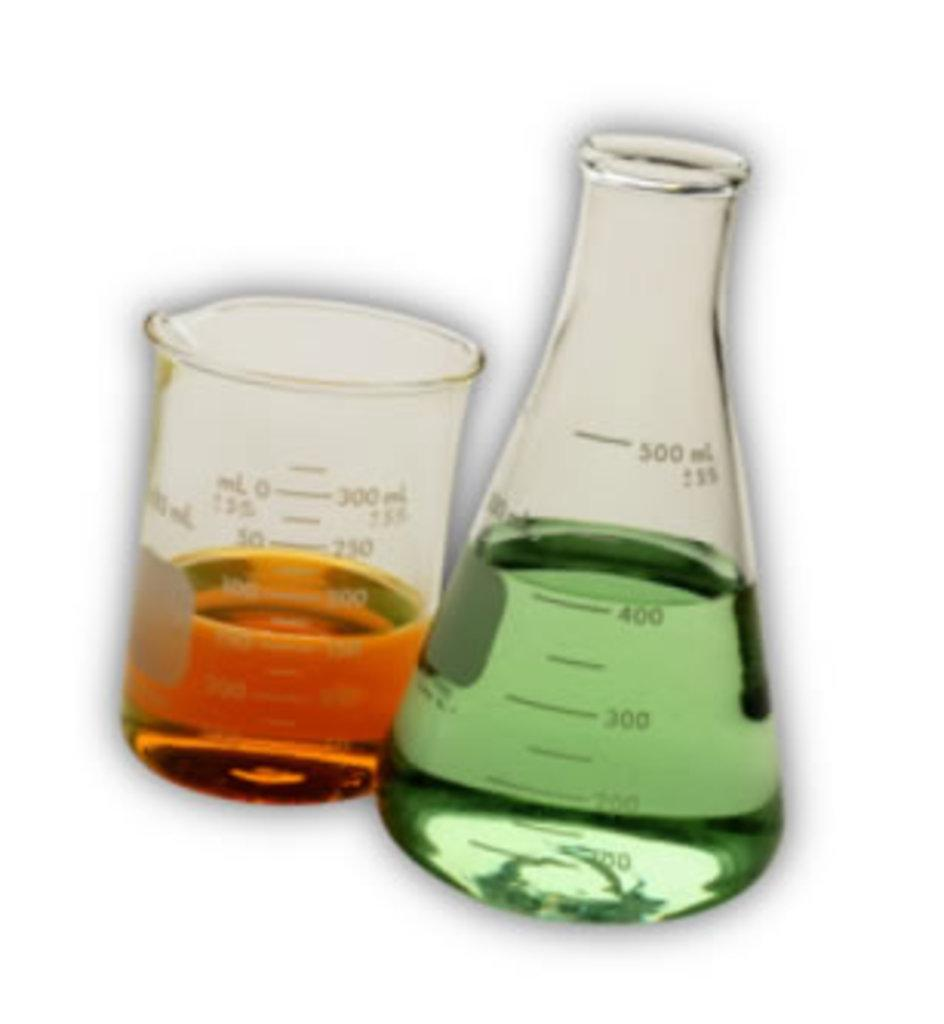<image>
Offer a succinct explanation of the picture presented. Two beakers, one with 300 ml capacity and the other with 500 ml capacity, are partially filled with liquid. 